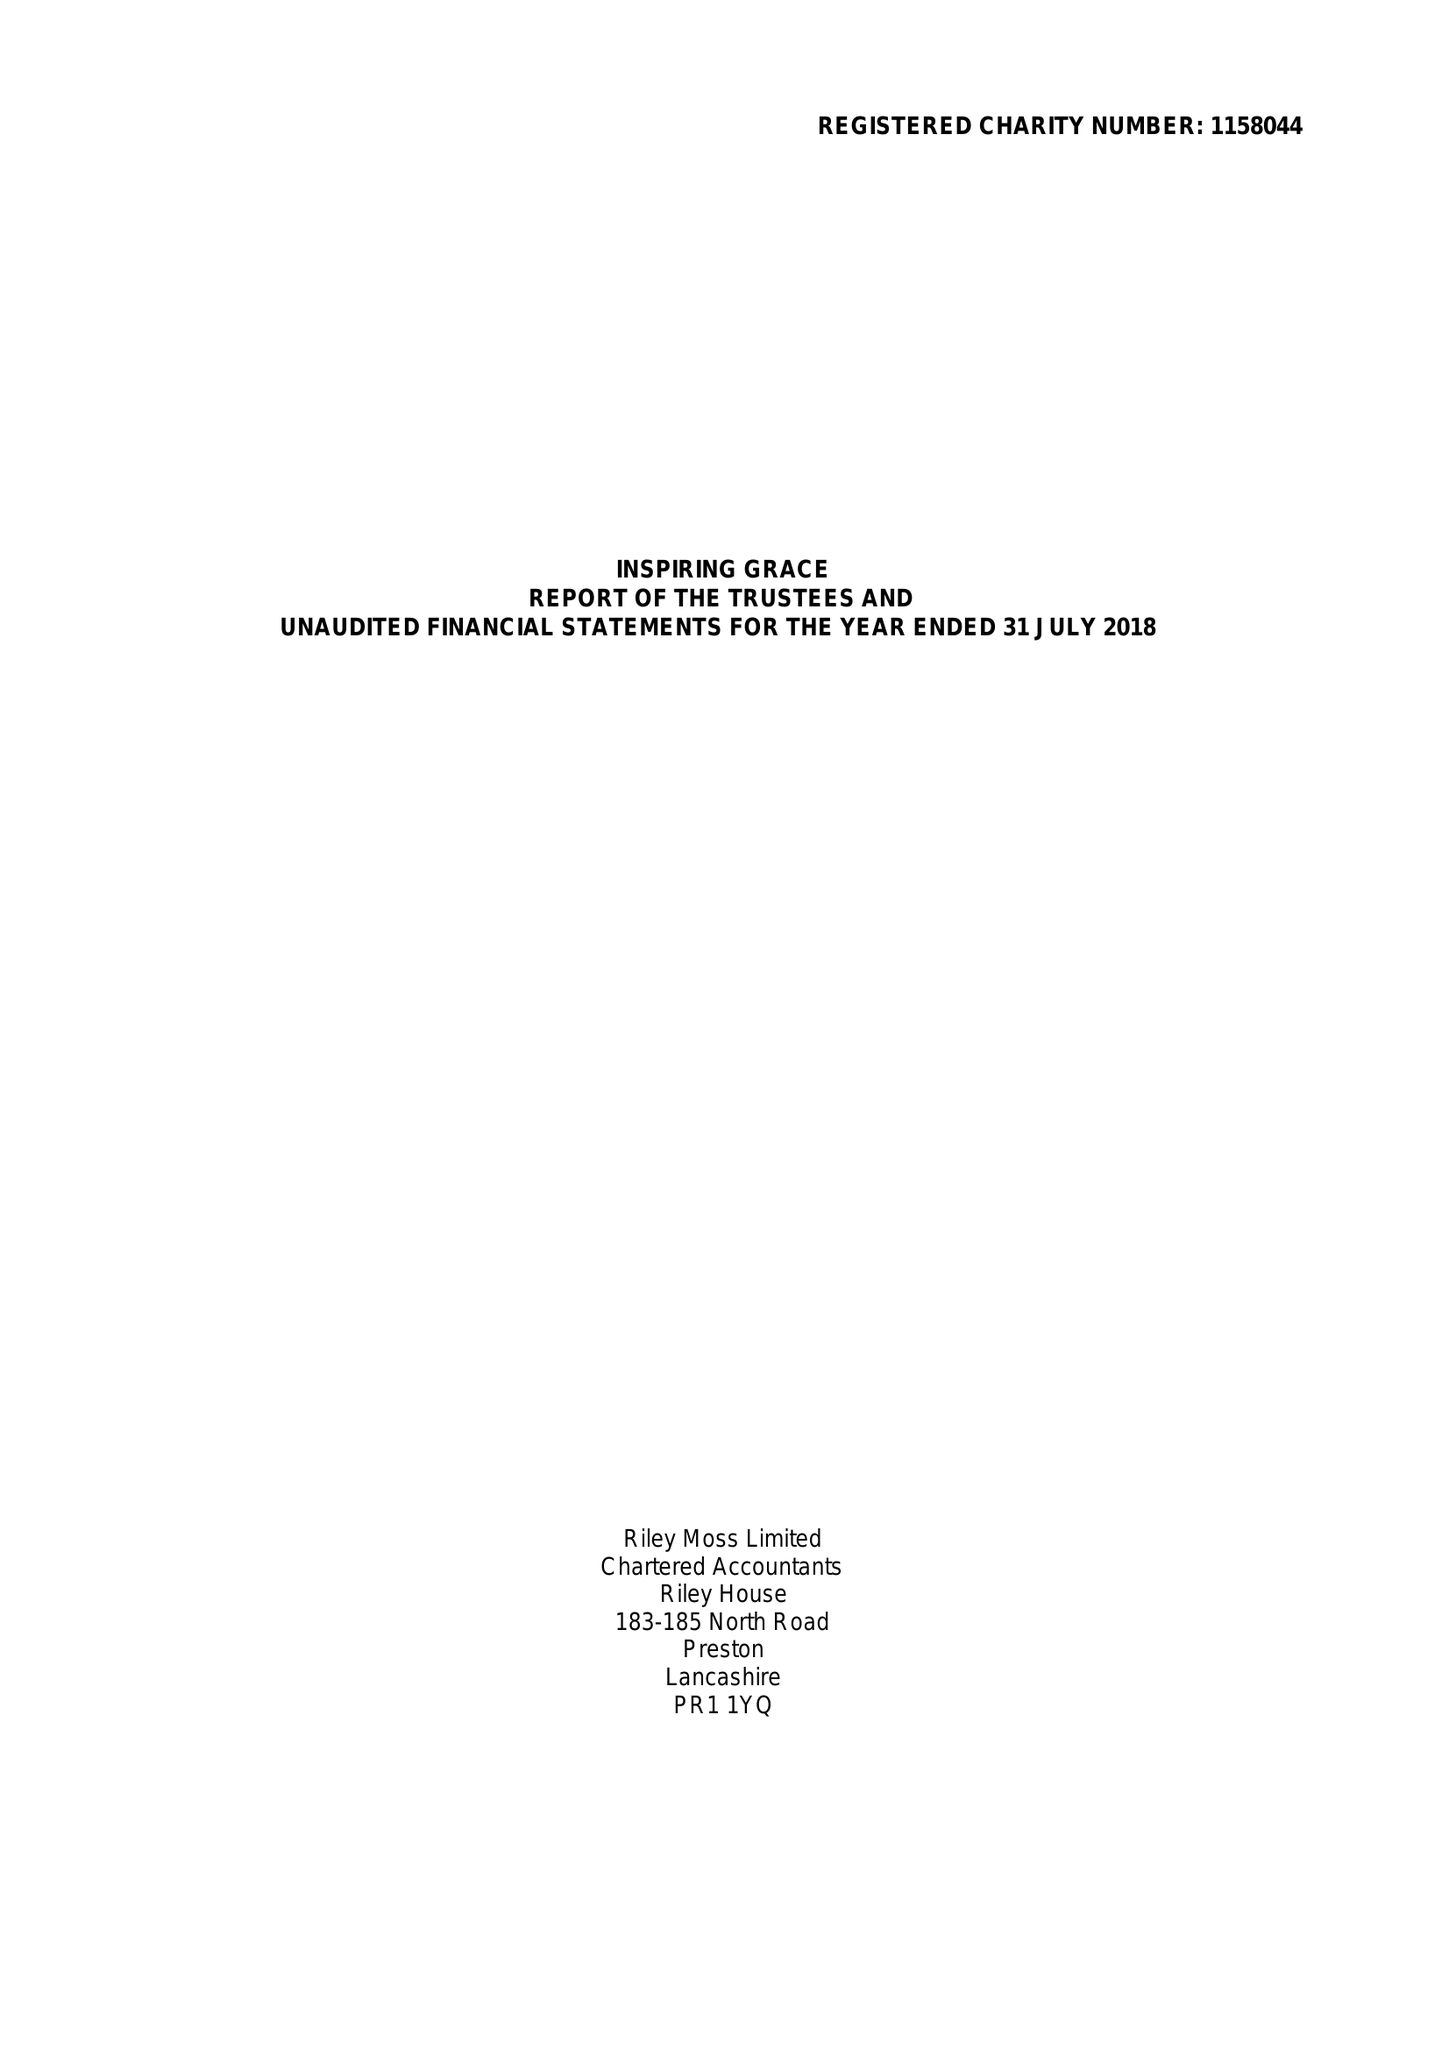What is the value for the charity_name?
Answer the question using a single word or phrase. Inspiring Grace 